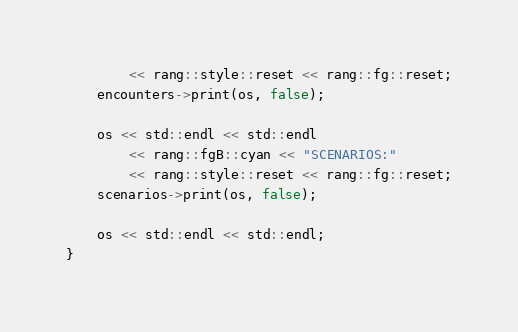Convert code to text. <code><loc_0><loc_0><loc_500><loc_500><_C++_>        << rang::style::reset << rang::fg::reset;
    encounters->print(os, false);

    os << std::endl << std::endl
        << rang::fgB::cyan << "SCENARIOS:"
        << rang::style::reset << rang::fg::reset;
    scenarios->print(os, false);

    os << std::endl << std::endl;
}
</code> 